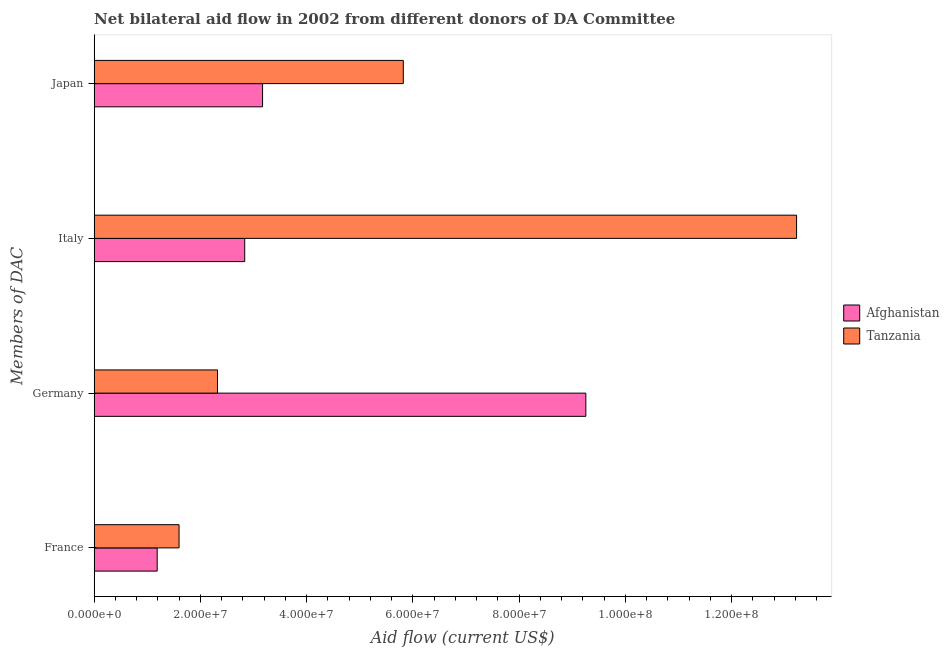How many different coloured bars are there?
Offer a very short reply. 2. How many groups of bars are there?
Your answer should be compact. 4. What is the label of the 2nd group of bars from the top?
Provide a short and direct response. Italy. What is the amount of aid given by france in Tanzania?
Provide a succinct answer. 1.60e+07. Across all countries, what is the maximum amount of aid given by japan?
Make the answer very short. 5.82e+07. Across all countries, what is the minimum amount of aid given by italy?
Keep it short and to the point. 2.83e+07. In which country was the amount of aid given by germany maximum?
Your response must be concise. Afghanistan. In which country was the amount of aid given by france minimum?
Provide a short and direct response. Afghanistan. What is the total amount of aid given by france in the graph?
Your answer should be very brief. 2.78e+07. What is the difference between the amount of aid given by italy in Tanzania and that in Afghanistan?
Provide a short and direct response. 1.04e+08. What is the difference between the amount of aid given by france in Tanzania and the amount of aid given by germany in Afghanistan?
Your answer should be compact. -7.66e+07. What is the average amount of aid given by japan per country?
Your answer should be compact. 4.50e+07. What is the difference between the amount of aid given by germany and amount of aid given by italy in Afghanistan?
Your answer should be very brief. 6.42e+07. What is the ratio of the amount of aid given by japan in Afghanistan to that in Tanzania?
Make the answer very short. 0.54. What is the difference between the highest and the second highest amount of aid given by japan?
Provide a succinct answer. 2.65e+07. What is the difference between the highest and the lowest amount of aid given by germany?
Offer a terse response. 6.94e+07. In how many countries, is the amount of aid given by italy greater than the average amount of aid given by italy taken over all countries?
Make the answer very short. 1. Is it the case that in every country, the sum of the amount of aid given by japan and amount of aid given by germany is greater than the sum of amount of aid given by italy and amount of aid given by france?
Make the answer very short. No. What does the 2nd bar from the top in France represents?
Offer a terse response. Afghanistan. What does the 1st bar from the bottom in Germany represents?
Give a very brief answer. Afghanistan. How many bars are there?
Make the answer very short. 8. Are the values on the major ticks of X-axis written in scientific E-notation?
Your response must be concise. Yes. How many legend labels are there?
Your answer should be compact. 2. How are the legend labels stacked?
Your answer should be compact. Vertical. What is the title of the graph?
Offer a terse response. Net bilateral aid flow in 2002 from different donors of DA Committee. Does "Botswana" appear as one of the legend labels in the graph?
Your answer should be very brief. No. What is the label or title of the X-axis?
Offer a terse response. Aid flow (current US$). What is the label or title of the Y-axis?
Make the answer very short. Members of DAC. What is the Aid flow (current US$) of Afghanistan in France?
Offer a very short reply. 1.19e+07. What is the Aid flow (current US$) in Tanzania in France?
Your response must be concise. 1.60e+07. What is the Aid flow (current US$) of Afghanistan in Germany?
Give a very brief answer. 9.26e+07. What is the Aid flow (current US$) in Tanzania in Germany?
Offer a terse response. 2.32e+07. What is the Aid flow (current US$) of Afghanistan in Italy?
Keep it short and to the point. 2.83e+07. What is the Aid flow (current US$) in Tanzania in Italy?
Provide a succinct answer. 1.32e+08. What is the Aid flow (current US$) of Afghanistan in Japan?
Make the answer very short. 3.17e+07. What is the Aid flow (current US$) in Tanzania in Japan?
Your response must be concise. 5.82e+07. Across all Members of DAC, what is the maximum Aid flow (current US$) in Afghanistan?
Provide a succinct answer. 9.26e+07. Across all Members of DAC, what is the maximum Aid flow (current US$) of Tanzania?
Ensure brevity in your answer.  1.32e+08. Across all Members of DAC, what is the minimum Aid flow (current US$) of Afghanistan?
Ensure brevity in your answer.  1.19e+07. Across all Members of DAC, what is the minimum Aid flow (current US$) in Tanzania?
Your answer should be very brief. 1.60e+07. What is the total Aid flow (current US$) of Afghanistan in the graph?
Offer a terse response. 1.64e+08. What is the total Aid flow (current US$) in Tanzania in the graph?
Your answer should be compact. 2.30e+08. What is the difference between the Aid flow (current US$) in Afghanistan in France and that in Germany?
Ensure brevity in your answer.  -8.07e+07. What is the difference between the Aid flow (current US$) of Tanzania in France and that in Germany?
Your answer should be compact. -7.24e+06. What is the difference between the Aid flow (current US$) in Afghanistan in France and that in Italy?
Provide a short and direct response. -1.65e+07. What is the difference between the Aid flow (current US$) of Tanzania in France and that in Italy?
Your answer should be very brief. -1.16e+08. What is the difference between the Aid flow (current US$) of Afghanistan in France and that in Japan?
Your answer should be very brief. -1.98e+07. What is the difference between the Aid flow (current US$) in Tanzania in France and that in Japan?
Offer a terse response. -4.22e+07. What is the difference between the Aid flow (current US$) in Afghanistan in Germany and that in Italy?
Provide a succinct answer. 6.42e+07. What is the difference between the Aid flow (current US$) of Tanzania in Germany and that in Italy?
Your answer should be compact. -1.09e+08. What is the difference between the Aid flow (current US$) of Afghanistan in Germany and that in Japan?
Provide a succinct answer. 6.09e+07. What is the difference between the Aid flow (current US$) in Tanzania in Germany and that in Japan?
Your answer should be compact. -3.50e+07. What is the difference between the Aid flow (current US$) in Afghanistan in Italy and that in Japan?
Provide a short and direct response. -3.36e+06. What is the difference between the Aid flow (current US$) in Tanzania in Italy and that in Japan?
Your answer should be very brief. 7.40e+07. What is the difference between the Aid flow (current US$) of Afghanistan in France and the Aid flow (current US$) of Tanzania in Germany?
Keep it short and to the point. -1.14e+07. What is the difference between the Aid flow (current US$) of Afghanistan in France and the Aid flow (current US$) of Tanzania in Italy?
Your answer should be compact. -1.20e+08. What is the difference between the Aid flow (current US$) in Afghanistan in France and the Aid flow (current US$) in Tanzania in Japan?
Keep it short and to the point. -4.63e+07. What is the difference between the Aid flow (current US$) in Afghanistan in Germany and the Aid flow (current US$) in Tanzania in Italy?
Provide a short and direct response. -3.97e+07. What is the difference between the Aid flow (current US$) of Afghanistan in Germany and the Aid flow (current US$) of Tanzania in Japan?
Provide a short and direct response. 3.44e+07. What is the difference between the Aid flow (current US$) in Afghanistan in Italy and the Aid flow (current US$) in Tanzania in Japan?
Ensure brevity in your answer.  -2.99e+07. What is the average Aid flow (current US$) in Afghanistan per Members of DAC?
Provide a succinct answer. 4.11e+07. What is the average Aid flow (current US$) of Tanzania per Members of DAC?
Give a very brief answer. 5.74e+07. What is the difference between the Aid flow (current US$) of Afghanistan and Aid flow (current US$) of Tanzania in France?
Ensure brevity in your answer.  -4.12e+06. What is the difference between the Aid flow (current US$) in Afghanistan and Aid flow (current US$) in Tanzania in Germany?
Provide a short and direct response. 6.94e+07. What is the difference between the Aid flow (current US$) in Afghanistan and Aid flow (current US$) in Tanzania in Italy?
Ensure brevity in your answer.  -1.04e+08. What is the difference between the Aid flow (current US$) of Afghanistan and Aid flow (current US$) of Tanzania in Japan?
Your answer should be compact. -2.65e+07. What is the ratio of the Aid flow (current US$) of Afghanistan in France to that in Germany?
Your response must be concise. 0.13. What is the ratio of the Aid flow (current US$) of Tanzania in France to that in Germany?
Your response must be concise. 0.69. What is the ratio of the Aid flow (current US$) of Afghanistan in France to that in Italy?
Give a very brief answer. 0.42. What is the ratio of the Aid flow (current US$) of Tanzania in France to that in Italy?
Offer a terse response. 0.12. What is the ratio of the Aid flow (current US$) of Afghanistan in France to that in Japan?
Your response must be concise. 0.37. What is the ratio of the Aid flow (current US$) in Tanzania in France to that in Japan?
Provide a short and direct response. 0.27. What is the ratio of the Aid flow (current US$) of Afghanistan in Germany to that in Italy?
Keep it short and to the point. 3.27. What is the ratio of the Aid flow (current US$) of Tanzania in Germany to that in Italy?
Provide a short and direct response. 0.18. What is the ratio of the Aid flow (current US$) in Afghanistan in Germany to that in Japan?
Keep it short and to the point. 2.92. What is the ratio of the Aid flow (current US$) of Tanzania in Germany to that in Japan?
Your answer should be compact. 0.4. What is the ratio of the Aid flow (current US$) of Afghanistan in Italy to that in Japan?
Provide a short and direct response. 0.89. What is the ratio of the Aid flow (current US$) of Tanzania in Italy to that in Japan?
Provide a short and direct response. 2.27. What is the difference between the highest and the second highest Aid flow (current US$) of Afghanistan?
Provide a short and direct response. 6.09e+07. What is the difference between the highest and the second highest Aid flow (current US$) in Tanzania?
Make the answer very short. 7.40e+07. What is the difference between the highest and the lowest Aid flow (current US$) in Afghanistan?
Give a very brief answer. 8.07e+07. What is the difference between the highest and the lowest Aid flow (current US$) of Tanzania?
Offer a terse response. 1.16e+08. 